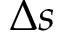<formula> <loc_0><loc_0><loc_500><loc_500>\Delta s</formula> 